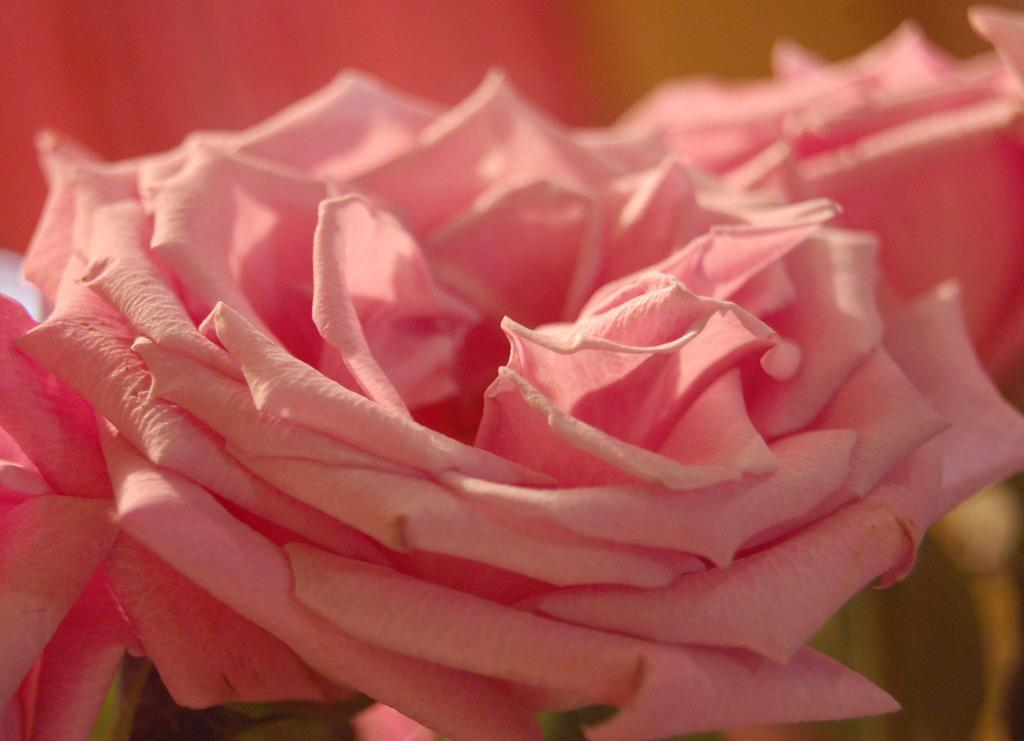What is present in the picture? There is a flower in the picture. Can you describe the flower in the picture? The flower is pink in color. Can you see any windows in the picture? There is no mention of a window in the provided facts, so it cannot be determined if a window is present in the image. Is the flower in the picture capable of performing magic? The provided facts do not mention anything about magic, so it cannot be determined if the flower is capable of performing magic. 